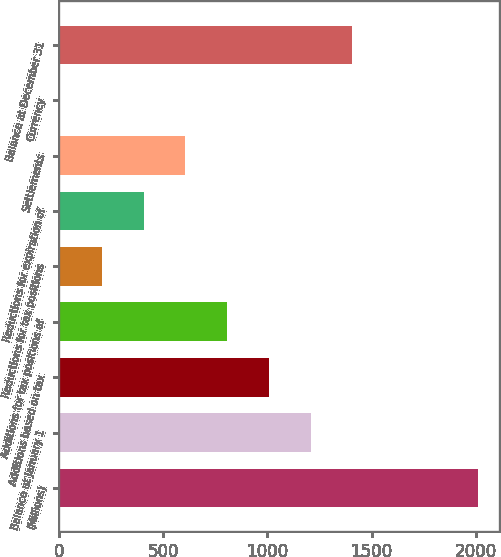<chart> <loc_0><loc_0><loc_500><loc_500><bar_chart><fcel>(Millions)<fcel>Balance at January 1<fcel>Additions based on tax<fcel>Additions for tax positions of<fcel>Reductions for tax positions<fcel>Reductions for expiration of<fcel>Settlements<fcel>Currency<fcel>Balance at December 31<nl><fcel>2009<fcel>1207.4<fcel>1007<fcel>806.6<fcel>205.4<fcel>405.8<fcel>606.2<fcel>5<fcel>1407.8<nl></chart> 